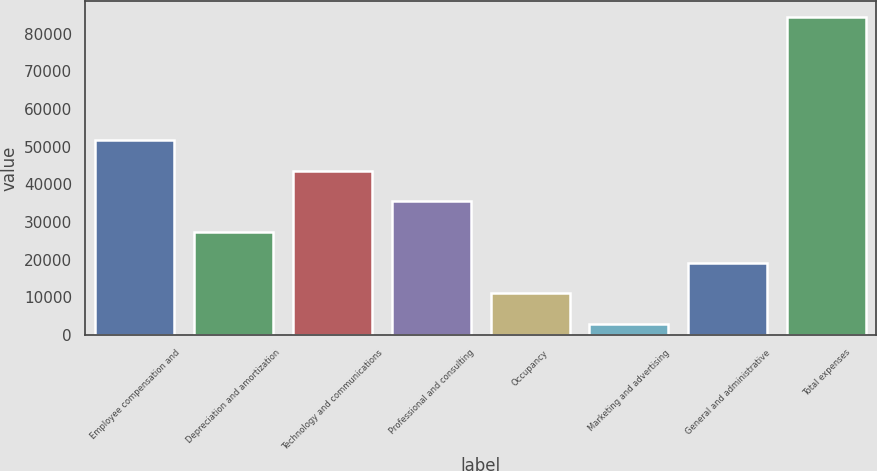<chart> <loc_0><loc_0><loc_500><loc_500><bar_chart><fcel>Employee compensation and<fcel>Depreciation and amortization<fcel>Technology and communications<fcel>Professional and consulting<fcel>Occupancy<fcel>Marketing and advertising<fcel>General and administrative<fcel>Total expenses<nl><fcel>51786.8<fcel>27334.4<fcel>43636<fcel>35485.2<fcel>11032.8<fcel>2882<fcel>19183.6<fcel>84390<nl></chart> 